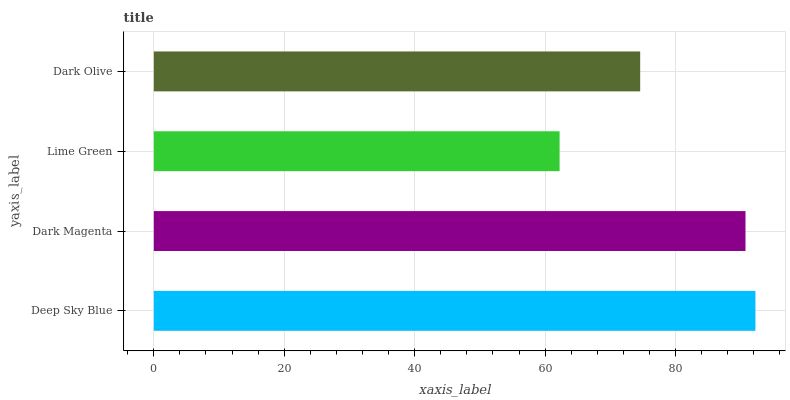Is Lime Green the minimum?
Answer yes or no. Yes. Is Deep Sky Blue the maximum?
Answer yes or no. Yes. Is Dark Magenta the minimum?
Answer yes or no. No. Is Dark Magenta the maximum?
Answer yes or no. No. Is Deep Sky Blue greater than Dark Magenta?
Answer yes or no. Yes. Is Dark Magenta less than Deep Sky Blue?
Answer yes or no. Yes. Is Dark Magenta greater than Deep Sky Blue?
Answer yes or no. No. Is Deep Sky Blue less than Dark Magenta?
Answer yes or no. No. Is Dark Magenta the high median?
Answer yes or no. Yes. Is Dark Olive the low median?
Answer yes or no. Yes. Is Lime Green the high median?
Answer yes or no. No. Is Lime Green the low median?
Answer yes or no. No. 